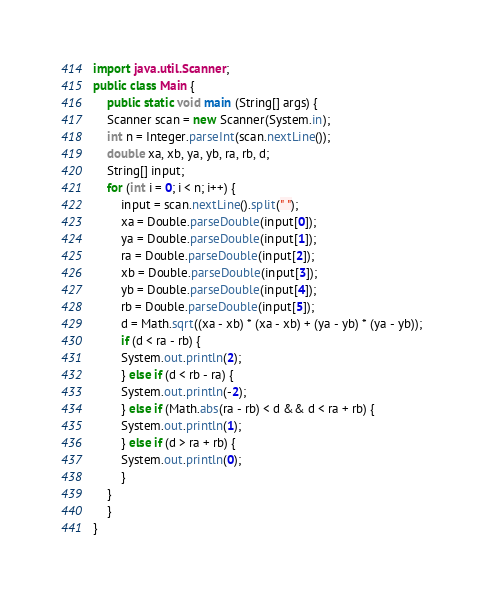Convert code to text. <code><loc_0><loc_0><loc_500><loc_500><_Java_>import java.util.Scanner;
public class Main {
    public static void main (String[] args) {
	Scanner scan = new Scanner(System.in);
	int n = Integer.parseInt(scan.nextLine());
	double xa, xb, ya, yb, ra, rb, d;
	String[] input;
	for (int i = 0; i < n; i++) {
	    input = scan.nextLine().split(" ");
	    xa = Double.parseDouble(input[0]);
	    ya = Double.parseDouble(input[1]);
	    ra = Double.parseDouble(input[2]);
	    xb = Double.parseDouble(input[3]);
	    yb = Double.parseDouble(input[4]);
	    rb = Double.parseDouble(input[5]);
	    d = Math.sqrt((xa - xb) * (xa - xb) + (ya - yb) * (ya - yb));
	    if (d < ra - rb) {
		System.out.println(2);
	    } else if (d < rb - ra) {
		System.out.println(-2);
	    } else if (Math.abs(ra - rb) < d && d < ra + rb) {
		System.out.println(1);
	    } else if (d > ra + rb) {
		System.out.println(0);
	    }
	}
    }
}</code> 